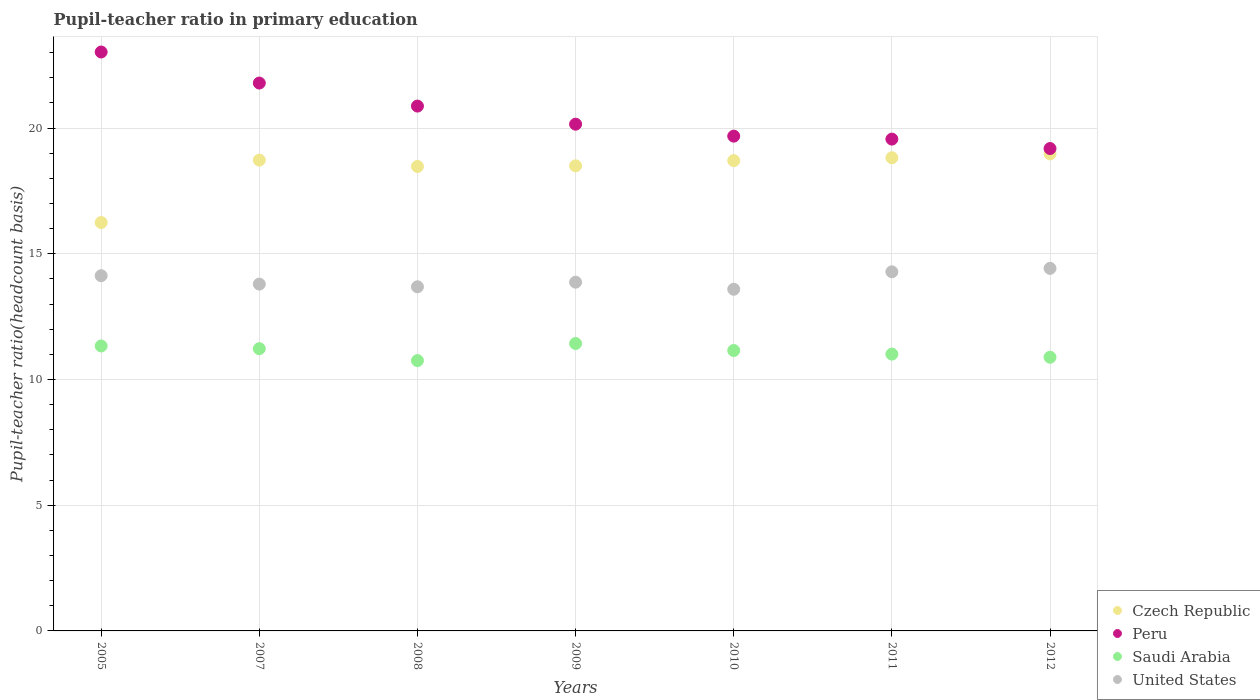How many different coloured dotlines are there?
Make the answer very short. 4. Is the number of dotlines equal to the number of legend labels?
Ensure brevity in your answer.  Yes. What is the pupil-teacher ratio in primary education in Peru in 2012?
Offer a very short reply. 19.19. Across all years, what is the maximum pupil-teacher ratio in primary education in Czech Republic?
Offer a terse response. 18.97. Across all years, what is the minimum pupil-teacher ratio in primary education in Saudi Arabia?
Provide a succinct answer. 10.75. In which year was the pupil-teacher ratio in primary education in Czech Republic maximum?
Give a very brief answer. 2012. What is the total pupil-teacher ratio in primary education in Saudi Arabia in the graph?
Keep it short and to the point. 77.8. What is the difference between the pupil-teacher ratio in primary education in United States in 2005 and that in 2009?
Provide a succinct answer. 0.26. What is the difference between the pupil-teacher ratio in primary education in Peru in 2005 and the pupil-teacher ratio in primary education in United States in 2008?
Offer a very short reply. 9.34. What is the average pupil-teacher ratio in primary education in Czech Republic per year?
Give a very brief answer. 18.35. In the year 2008, what is the difference between the pupil-teacher ratio in primary education in Peru and pupil-teacher ratio in primary education in Czech Republic?
Make the answer very short. 2.4. What is the ratio of the pupil-teacher ratio in primary education in Peru in 2007 to that in 2009?
Your response must be concise. 1.08. Is the pupil-teacher ratio in primary education in United States in 2010 less than that in 2011?
Ensure brevity in your answer.  Yes. What is the difference between the highest and the second highest pupil-teacher ratio in primary education in Peru?
Your answer should be very brief. 1.23. What is the difference between the highest and the lowest pupil-teacher ratio in primary education in Peru?
Your answer should be very brief. 3.84. In how many years, is the pupil-teacher ratio in primary education in Peru greater than the average pupil-teacher ratio in primary education in Peru taken over all years?
Give a very brief answer. 3. Is it the case that in every year, the sum of the pupil-teacher ratio in primary education in Czech Republic and pupil-teacher ratio in primary education in Saudi Arabia  is greater than the sum of pupil-teacher ratio in primary education in Peru and pupil-teacher ratio in primary education in United States?
Offer a very short reply. No. Is it the case that in every year, the sum of the pupil-teacher ratio in primary education in Czech Republic and pupil-teacher ratio in primary education in United States  is greater than the pupil-teacher ratio in primary education in Peru?
Provide a succinct answer. Yes. Does the pupil-teacher ratio in primary education in Peru monotonically increase over the years?
Keep it short and to the point. No. Is the pupil-teacher ratio in primary education in Czech Republic strictly greater than the pupil-teacher ratio in primary education in United States over the years?
Give a very brief answer. Yes. Is the pupil-teacher ratio in primary education in Czech Republic strictly less than the pupil-teacher ratio in primary education in Saudi Arabia over the years?
Keep it short and to the point. No. How many years are there in the graph?
Provide a short and direct response. 7. Are the values on the major ticks of Y-axis written in scientific E-notation?
Provide a short and direct response. No. Where does the legend appear in the graph?
Give a very brief answer. Bottom right. How are the legend labels stacked?
Offer a very short reply. Vertical. What is the title of the graph?
Your answer should be compact. Pupil-teacher ratio in primary education. Does "Netherlands" appear as one of the legend labels in the graph?
Your response must be concise. No. What is the label or title of the Y-axis?
Provide a short and direct response. Pupil-teacher ratio(headcount basis). What is the Pupil-teacher ratio(headcount basis) in Czech Republic in 2005?
Provide a succinct answer. 16.25. What is the Pupil-teacher ratio(headcount basis) in Peru in 2005?
Your response must be concise. 23.03. What is the Pupil-teacher ratio(headcount basis) in Saudi Arabia in 2005?
Offer a terse response. 11.33. What is the Pupil-teacher ratio(headcount basis) in United States in 2005?
Keep it short and to the point. 14.13. What is the Pupil-teacher ratio(headcount basis) in Czech Republic in 2007?
Your answer should be compact. 18.73. What is the Pupil-teacher ratio(headcount basis) of Peru in 2007?
Make the answer very short. 21.79. What is the Pupil-teacher ratio(headcount basis) in Saudi Arabia in 2007?
Give a very brief answer. 11.23. What is the Pupil-teacher ratio(headcount basis) of United States in 2007?
Offer a terse response. 13.8. What is the Pupil-teacher ratio(headcount basis) in Czech Republic in 2008?
Provide a succinct answer. 18.48. What is the Pupil-teacher ratio(headcount basis) in Peru in 2008?
Your answer should be very brief. 20.88. What is the Pupil-teacher ratio(headcount basis) in Saudi Arabia in 2008?
Keep it short and to the point. 10.75. What is the Pupil-teacher ratio(headcount basis) of United States in 2008?
Make the answer very short. 13.69. What is the Pupil-teacher ratio(headcount basis) of Czech Republic in 2009?
Your answer should be very brief. 18.5. What is the Pupil-teacher ratio(headcount basis) in Peru in 2009?
Keep it short and to the point. 20.16. What is the Pupil-teacher ratio(headcount basis) of Saudi Arabia in 2009?
Ensure brevity in your answer.  11.43. What is the Pupil-teacher ratio(headcount basis) in United States in 2009?
Your answer should be very brief. 13.87. What is the Pupil-teacher ratio(headcount basis) of Czech Republic in 2010?
Keep it short and to the point. 18.71. What is the Pupil-teacher ratio(headcount basis) of Peru in 2010?
Offer a terse response. 19.68. What is the Pupil-teacher ratio(headcount basis) in Saudi Arabia in 2010?
Your response must be concise. 11.15. What is the Pupil-teacher ratio(headcount basis) in United States in 2010?
Provide a short and direct response. 13.59. What is the Pupil-teacher ratio(headcount basis) of Czech Republic in 2011?
Offer a terse response. 18.82. What is the Pupil-teacher ratio(headcount basis) of Peru in 2011?
Offer a terse response. 19.56. What is the Pupil-teacher ratio(headcount basis) in Saudi Arabia in 2011?
Make the answer very short. 11.01. What is the Pupil-teacher ratio(headcount basis) in United States in 2011?
Your answer should be compact. 14.29. What is the Pupil-teacher ratio(headcount basis) in Czech Republic in 2012?
Your answer should be very brief. 18.97. What is the Pupil-teacher ratio(headcount basis) in Peru in 2012?
Your answer should be very brief. 19.19. What is the Pupil-teacher ratio(headcount basis) of Saudi Arabia in 2012?
Offer a very short reply. 10.89. What is the Pupil-teacher ratio(headcount basis) in United States in 2012?
Your response must be concise. 14.42. Across all years, what is the maximum Pupil-teacher ratio(headcount basis) in Czech Republic?
Provide a short and direct response. 18.97. Across all years, what is the maximum Pupil-teacher ratio(headcount basis) of Peru?
Offer a very short reply. 23.03. Across all years, what is the maximum Pupil-teacher ratio(headcount basis) in Saudi Arabia?
Offer a very short reply. 11.43. Across all years, what is the maximum Pupil-teacher ratio(headcount basis) of United States?
Offer a very short reply. 14.42. Across all years, what is the minimum Pupil-teacher ratio(headcount basis) in Czech Republic?
Give a very brief answer. 16.25. Across all years, what is the minimum Pupil-teacher ratio(headcount basis) in Peru?
Give a very brief answer. 19.19. Across all years, what is the minimum Pupil-teacher ratio(headcount basis) in Saudi Arabia?
Ensure brevity in your answer.  10.75. Across all years, what is the minimum Pupil-teacher ratio(headcount basis) in United States?
Offer a very short reply. 13.59. What is the total Pupil-teacher ratio(headcount basis) of Czech Republic in the graph?
Make the answer very short. 128.45. What is the total Pupil-teacher ratio(headcount basis) of Peru in the graph?
Your answer should be very brief. 144.29. What is the total Pupil-teacher ratio(headcount basis) in Saudi Arabia in the graph?
Your answer should be very brief. 77.8. What is the total Pupil-teacher ratio(headcount basis) of United States in the graph?
Keep it short and to the point. 97.78. What is the difference between the Pupil-teacher ratio(headcount basis) of Czech Republic in 2005 and that in 2007?
Make the answer very short. -2.48. What is the difference between the Pupil-teacher ratio(headcount basis) of Peru in 2005 and that in 2007?
Make the answer very short. 1.23. What is the difference between the Pupil-teacher ratio(headcount basis) of Saudi Arabia in 2005 and that in 2007?
Keep it short and to the point. 0.11. What is the difference between the Pupil-teacher ratio(headcount basis) in United States in 2005 and that in 2007?
Keep it short and to the point. 0.33. What is the difference between the Pupil-teacher ratio(headcount basis) in Czech Republic in 2005 and that in 2008?
Provide a short and direct response. -2.23. What is the difference between the Pupil-teacher ratio(headcount basis) in Peru in 2005 and that in 2008?
Provide a short and direct response. 2.15. What is the difference between the Pupil-teacher ratio(headcount basis) of Saudi Arabia in 2005 and that in 2008?
Provide a short and direct response. 0.58. What is the difference between the Pupil-teacher ratio(headcount basis) in United States in 2005 and that in 2008?
Your answer should be very brief. 0.44. What is the difference between the Pupil-teacher ratio(headcount basis) of Czech Republic in 2005 and that in 2009?
Make the answer very short. -2.26. What is the difference between the Pupil-teacher ratio(headcount basis) in Peru in 2005 and that in 2009?
Offer a terse response. 2.87. What is the difference between the Pupil-teacher ratio(headcount basis) of Saudi Arabia in 2005 and that in 2009?
Offer a very short reply. -0.1. What is the difference between the Pupil-teacher ratio(headcount basis) in United States in 2005 and that in 2009?
Offer a very short reply. 0.26. What is the difference between the Pupil-teacher ratio(headcount basis) of Czech Republic in 2005 and that in 2010?
Offer a very short reply. -2.46. What is the difference between the Pupil-teacher ratio(headcount basis) of Peru in 2005 and that in 2010?
Ensure brevity in your answer.  3.35. What is the difference between the Pupil-teacher ratio(headcount basis) of Saudi Arabia in 2005 and that in 2010?
Your answer should be compact. 0.18. What is the difference between the Pupil-teacher ratio(headcount basis) in United States in 2005 and that in 2010?
Your answer should be compact. 0.54. What is the difference between the Pupil-teacher ratio(headcount basis) in Czech Republic in 2005 and that in 2011?
Offer a very short reply. -2.58. What is the difference between the Pupil-teacher ratio(headcount basis) of Peru in 2005 and that in 2011?
Provide a short and direct response. 3.46. What is the difference between the Pupil-teacher ratio(headcount basis) of Saudi Arabia in 2005 and that in 2011?
Provide a short and direct response. 0.32. What is the difference between the Pupil-teacher ratio(headcount basis) in United States in 2005 and that in 2011?
Your answer should be very brief. -0.16. What is the difference between the Pupil-teacher ratio(headcount basis) of Czech Republic in 2005 and that in 2012?
Provide a short and direct response. -2.73. What is the difference between the Pupil-teacher ratio(headcount basis) of Peru in 2005 and that in 2012?
Keep it short and to the point. 3.84. What is the difference between the Pupil-teacher ratio(headcount basis) in Saudi Arabia in 2005 and that in 2012?
Make the answer very short. 0.45. What is the difference between the Pupil-teacher ratio(headcount basis) in United States in 2005 and that in 2012?
Your answer should be very brief. -0.29. What is the difference between the Pupil-teacher ratio(headcount basis) of Czech Republic in 2007 and that in 2008?
Give a very brief answer. 0.25. What is the difference between the Pupil-teacher ratio(headcount basis) of Peru in 2007 and that in 2008?
Your response must be concise. 0.92. What is the difference between the Pupil-teacher ratio(headcount basis) of Saudi Arabia in 2007 and that in 2008?
Provide a succinct answer. 0.47. What is the difference between the Pupil-teacher ratio(headcount basis) of United States in 2007 and that in 2008?
Your response must be concise. 0.11. What is the difference between the Pupil-teacher ratio(headcount basis) in Czech Republic in 2007 and that in 2009?
Your response must be concise. 0.23. What is the difference between the Pupil-teacher ratio(headcount basis) of Peru in 2007 and that in 2009?
Ensure brevity in your answer.  1.64. What is the difference between the Pupil-teacher ratio(headcount basis) of Saudi Arabia in 2007 and that in 2009?
Provide a succinct answer. -0.2. What is the difference between the Pupil-teacher ratio(headcount basis) in United States in 2007 and that in 2009?
Keep it short and to the point. -0.08. What is the difference between the Pupil-teacher ratio(headcount basis) in Czech Republic in 2007 and that in 2010?
Provide a short and direct response. 0.02. What is the difference between the Pupil-teacher ratio(headcount basis) of Peru in 2007 and that in 2010?
Ensure brevity in your answer.  2.11. What is the difference between the Pupil-teacher ratio(headcount basis) in Saudi Arabia in 2007 and that in 2010?
Provide a succinct answer. 0.07. What is the difference between the Pupil-teacher ratio(headcount basis) in United States in 2007 and that in 2010?
Provide a succinct answer. 0.2. What is the difference between the Pupil-teacher ratio(headcount basis) of Czech Republic in 2007 and that in 2011?
Ensure brevity in your answer.  -0.09. What is the difference between the Pupil-teacher ratio(headcount basis) of Peru in 2007 and that in 2011?
Ensure brevity in your answer.  2.23. What is the difference between the Pupil-teacher ratio(headcount basis) in Saudi Arabia in 2007 and that in 2011?
Your answer should be very brief. 0.22. What is the difference between the Pupil-teacher ratio(headcount basis) of United States in 2007 and that in 2011?
Keep it short and to the point. -0.49. What is the difference between the Pupil-teacher ratio(headcount basis) in Czech Republic in 2007 and that in 2012?
Provide a succinct answer. -0.25. What is the difference between the Pupil-teacher ratio(headcount basis) in Peru in 2007 and that in 2012?
Your answer should be compact. 2.6. What is the difference between the Pupil-teacher ratio(headcount basis) of Saudi Arabia in 2007 and that in 2012?
Ensure brevity in your answer.  0.34. What is the difference between the Pupil-teacher ratio(headcount basis) in United States in 2007 and that in 2012?
Provide a succinct answer. -0.63. What is the difference between the Pupil-teacher ratio(headcount basis) in Czech Republic in 2008 and that in 2009?
Give a very brief answer. -0.03. What is the difference between the Pupil-teacher ratio(headcount basis) in Peru in 2008 and that in 2009?
Keep it short and to the point. 0.72. What is the difference between the Pupil-teacher ratio(headcount basis) of Saudi Arabia in 2008 and that in 2009?
Give a very brief answer. -0.68. What is the difference between the Pupil-teacher ratio(headcount basis) in United States in 2008 and that in 2009?
Offer a very short reply. -0.18. What is the difference between the Pupil-teacher ratio(headcount basis) in Czech Republic in 2008 and that in 2010?
Your response must be concise. -0.23. What is the difference between the Pupil-teacher ratio(headcount basis) of Peru in 2008 and that in 2010?
Provide a succinct answer. 1.2. What is the difference between the Pupil-teacher ratio(headcount basis) of Saudi Arabia in 2008 and that in 2010?
Your response must be concise. -0.4. What is the difference between the Pupil-teacher ratio(headcount basis) in United States in 2008 and that in 2010?
Ensure brevity in your answer.  0.1. What is the difference between the Pupil-teacher ratio(headcount basis) in Czech Republic in 2008 and that in 2011?
Your answer should be compact. -0.35. What is the difference between the Pupil-teacher ratio(headcount basis) of Peru in 2008 and that in 2011?
Offer a terse response. 1.31. What is the difference between the Pupil-teacher ratio(headcount basis) in Saudi Arabia in 2008 and that in 2011?
Your answer should be compact. -0.26. What is the difference between the Pupil-teacher ratio(headcount basis) in United States in 2008 and that in 2011?
Offer a very short reply. -0.6. What is the difference between the Pupil-teacher ratio(headcount basis) of Czech Republic in 2008 and that in 2012?
Your answer should be very brief. -0.5. What is the difference between the Pupil-teacher ratio(headcount basis) of Peru in 2008 and that in 2012?
Offer a terse response. 1.69. What is the difference between the Pupil-teacher ratio(headcount basis) of Saudi Arabia in 2008 and that in 2012?
Offer a very short reply. -0.13. What is the difference between the Pupil-teacher ratio(headcount basis) in United States in 2008 and that in 2012?
Your answer should be very brief. -0.73. What is the difference between the Pupil-teacher ratio(headcount basis) of Czech Republic in 2009 and that in 2010?
Offer a terse response. -0.21. What is the difference between the Pupil-teacher ratio(headcount basis) of Peru in 2009 and that in 2010?
Provide a succinct answer. 0.48. What is the difference between the Pupil-teacher ratio(headcount basis) of Saudi Arabia in 2009 and that in 2010?
Your response must be concise. 0.28. What is the difference between the Pupil-teacher ratio(headcount basis) of United States in 2009 and that in 2010?
Keep it short and to the point. 0.28. What is the difference between the Pupil-teacher ratio(headcount basis) of Czech Republic in 2009 and that in 2011?
Your answer should be compact. -0.32. What is the difference between the Pupil-teacher ratio(headcount basis) in Peru in 2009 and that in 2011?
Provide a succinct answer. 0.59. What is the difference between the Pupil-teacher ratio(headcount basis) in Saudi Arabia in 2009 and that in 2011?
Keep it short and to the point. 0.42. What is the difference between the Pupil-teacher ratio(headcount basis) in United States in 2009 and that in 2011?
Keep it short and to the point. -0.41. What is the difference between the Pupil-teacher ratio(headcount basis) of Czech Republic in 2009 and that in 2012?
Your answer should be compact. -0.47. What is the difference between the Pupil-teacher ratio(headcount basis) of Peru in 2009 and that in 2012?
Provide a short and direct response. 0.97. What is the difference between the Pupil-teacher ratio(headcount basis) of Saudi Arabia in 2009 and that in 2012?
Offer a terse response. 0.54. What is the difference between the Pupil-teacher ratio(headcount basis) of United States in 2009 and that in 2012?
Give a very brief answer. -0.55. What is the difference between the Pupil-teacher ratio(headcount basis) of Czech Republic in 2010 and that in 2011?
Offer a terse response. -0.11. What is the difference between the Pupil-teacher ratio(headcount basis) in Peru in 2010 and that in 2011?
Offer a very short reply. 0.12. What is the difference between the Pupil-teacher ratio(headcount basis) in Saudi Arabia in 2010 and that in 2011?
Offer a very short reply. 0.14. What is the difference between the Pupil-teacher ratio(headcount basis) in United States in 2010 and that in 2011?
Your answer should be very brief. -0.69. What is the difference between the Pupil-teacher ratio(headcount basis) of Czech Republic in 2010 and that in 2012?
Offer a very short reply. -0.27. What is the difference between the Pupil-teacher ratio(headcount basis) of Peru in 2010 and that in 2012?
Your answer should be compact. 0.49. What is the difference between the Pupil-teacher ratio(headcount basis) of Saudi Arabia in 2010 and that in 2012?
Offer a very short reply. 0.27. What is the difference between the Pupil-teacher ratio(headcount basis) of United States in 2010 and that in 2012?
Make the answer very short. -0.83. What is the difference between the Pupil-teacher ratio(headcount basis) in Czech Republic in 2011 and that in 2012?
Ensure brevity in your answer.  -0.15. What is the difference between the Pupil-teacher ratio(headcount basis) of Peru in 2011 and that in 2012?
Provide a short and direct response. 0.38. What is the difference between the Pupil-teacher ratio(headcount basis) in Saudi Arabia in 2011 and that in 2012?
Provide a succinct answer. 0.12. What is the difference between the Pupil-teacher ratio(headcount basis) in United States in 2011 and that in 2012?
Offer a very short reply. -0.14. What is the difference between the Pupil-teacher ratio(headcount basis) of Czech Republic in 2005 and the Pupil-teacher ratio(headcount basis) of Peru in 2007?
Offer a terse response. -5.55. What is the difference between the Pupil-teacher ratio(headcount basis) in Czech Republic in 2005 and the Pupil-teacher ratio(headcount basis) in Saudi Arabia in 2007?
Make the answer very short. 5.02. What is the difference between the Pupil-teacher ratio(headcount basis) in Czech Republic in 2005 and the Pupil-teacher ratio(headcount basis) in United States in 2007?
Keep it short and to the point. 2.45. What is the difference between the Pupil-teacher ratio(headcount basis) of Peru in 2005 and the Pupil-teacher ratio(headcount basis) of Saudi Arabia in 2007?
Provide a short and direct response. 11.8. What is the difference between the Pupil-teacher ratio(headcount basis) of Peru in 2005 and the Pupil-teacher ratio(headcount basis) of United States in 2007?
Your response must be concise. 9.23. What is the difference between the Pupil-teacher ratio(headcount basis) in Saudi Arabia in 2005 and the Pupil-teacher ratio(headcount basis) in United States in 2007?
Your answer should be compact. -2.46. What is the difference between the Pupil-teacher ratio(headcount basis) in Czech Republic in 2005 and the Pupil-teacher ratio(headcount basis) in Peru in 2008?
Make the answer very short. -4.63. What is the difference between the Pupil-teacher ratio(headcount basis) in Czech Republic in 2005 and the Pupil-teacher ratio(headcount basis) in Saudi Arabia in 2008?
Ensure brevity in your answer.  5.49. What is the difference between the Pupil-teacher ratio(headcount basis) of Czech Republic in 2005 and the Pupil-teacher ratio(headcount basis) of United States in 2008?
Keep it short and to the point. 2.56. What is the difference between the Pupil-teacher ratio(headcount basis) of Peru in 2005 and the Pupil-teacher ratio(headcount basis) of Saudi Arabia in 2008?
Your answer should be compact. 12.27. What is the difference between the Pupil-teacher ratio(headcount basis) in Peru in 2005 and the Pupil-teacher ratio(headcount basis) in United States in 2008?
Your response must be concise. 9.34. What is the difference between the Pupil-teacher ratio(headcount basis) in Saudi Arabia in 2005 and the Pupil-teacher ratio(headcount basis) in United States in 2008?
Your response must be concise. -2.35. What is the difference between the Pupil-teacher ratio(headcount basis) of Czech Republic in 2005 and the Pupil-teacher ratio(headcount basis) of Peru in 2009?
Give a very brief answer. -3.91. What is the difference between the Pupil-teacher ratio(headcount basis) of Czech Republic in 2005 and the Pupil-teacher ratio(headcount basis) of Saudi Arabia in 2009?
Give a very brief answer. 4.81. What is the difference between the Pupil-teacher ratio(headcount basis) in Czech Republic in 2005 and the Pupil-teacher ratio(headcount basis) in United States in 2009?
Ensure brevity in your answer.  2.37. What is the difference between the Pupil-teacher ratio(headcount basis) in Peru in 2005 and the Pupil-teacher ratio(headcount basis) in Saudi Arabia in 2009?
Provide a succinct answer. 11.6. What is the difference between the Pupil-teacher ratio(headcount basis) in Peru in 2005 and the Pupil-teacher ratio(headcount basis) in United States in 2009?
Offer a terse response. 9.16. What is the difference between the Pupil-teacher ratio(headcount basis) in Saudi Arabia in 2005 and the Pupil-teacher ratio(headcount basis) in United States in 2009?
Your response must be concise. -2.54. What is the difference between the Pupil-teacher ratio(headcount basis) of Czech Republic in 2005 and the Pupil-teacher ratio(headcount basis) of Peru in 2010?
Make the answer very short. -3.44. What is the difference between the Pupil-teacher ratio(headcount basis) of Czech Republic in 2005 and the Pupil-teacher ratio(headcount basis) of Saudi Arabia in 2010?
Provide a succinct answer. 5.09. What is the difference between the Pupil-teacher ratio(headcount basis) of Czech Republic in 2005 and the Pupil-teacher ratio(headcount basis) of United States in 2010?
Provide a succinct answer. 2.65. What is the difference between the Pupil-teacher ratio(headcount basis) of Peru in 2005 and the Pupil-teacher ratio(headcount basis) of Saudi Arabia in 2010?
Provide a succinct answer. 11.87. What is the difference between the Pupil-teacher ratio(headcount basis) of Peru in 2005 and the Pupil-teacher ratio(headcount basis) of United States in 2010?
Give a very brief answer. 9.44. What is the difference between the Pupil-teacher ratio(headcount basis) in Saudi Arabia in 2005 and the Pupil-teacher ratio(headcount basis) in United States in 2010?
Ensure brevity in your answer.  -2.26. What is the difference between the Pupil-teacher ratio(headcount basis) in Czech Republic in 2005 and the Pupil-teacher ratio(headcount basis) in Peru in 2011?
Make the answer very short. -3.32. What is the difference between the Pupil-teacher ratio(headcount basis) of Czech Republic in 2005 and the Pupil-teacher ratio(headcount basis) of Saudi Arabia in 2011?
Give a very brief answer. 5.23. What is the difference between the Pupil-teacher ratio(headcount basis) in Czech Republic in 2005 and the Pupil-teacher ratio(headcount basis) in United States in 2011?
Your answer should be compact. 1.96. What is the difference between the Pupil-teacher ratio(headcount basis) of Peru in 2005 and the Pupil-teacher ratio(headcount basis) of Saudi Arabia in 2011?
Your response must be concise. 12.02. What is the difference between the Pupil-teacher ratio(headcount basis) of Peru in 2005 and the Pupil-teacher ratio(headcount basis) of United States in 2011?
Keep it short and to the point. 8.74. What is the difference between the Pupil-teacher ratio(headcount basis) of Saudi Arabia in 2005 and the Pupil-teacher ratio(headcount basis) of United States in 2011?
Ensure brevity in your answer.  -2.95. What is the difference between the Pupil-teacher ratio(headcount basis) in Czech Republic in 2005 and the Pupil-teacher ratio(headcount basis) in Peru in 2012?
Your answer should be very brief. -2.94. What is the difference between the Pupil-teacher ratio(headcount basis) of Czech Republic in 2005 and the Pupil-teacher ratio(headcount basis) of Saudi Arabia in 2012?
Your answer should be compact. 5.36. What is the difference between the Pupil-teacher ratio(headcount basis) of Czech Republic in 2005 and the Pupil-teacher ratio(headcount basis) of United States in 2012?
Offer a terse response. 1.82. What is the difference between the Pupil-teacher ratio(headcount basis) of Peru in 2005 and the Pupil-teacher ratio(headcount basis) of Saudi Arabia in 2012?
Provide a succinct answer. 12.14. What is the difference between the Pupil-teacher ratio(headcount basis) of Peru in 2005 and the Pupil-teacher ratio(headcount basis) of United States in 2012?
Offer a very short reply. 8.61. What is the difference between the Pupil-teacher ratio(headcount basis) in Saudi Arabia in 2005 and the Pupil-teacher ratio(headcount basis) in United States in 2012?
Offer a very short reply. -3.09. What is the difference between the Pupil-teacher ratio(headcount basis) of Czech Republic in 2007 and the Pupil-teacher ratio(headcount basis) of Peru in 2008?
Provide a succinct answer. -2.15. What is the difference between the Pupil-teacher ratio(headcount basis) in Czech Republic in 2007 and the Pupil-teacher ratio(headcount basis) in Saudi Arabia in 2008?
Give a very brief answer. 7.97. What is the difference between the Pupil-teacher ratio(headcount basis) of Czech Republic in 2007 and the Pupil-teacher ratio(headcount basis) of United States in 2008?
Offer a very short reply. 5.04. What is the difference between the Pupil-teacher ratio(headcount basis) of Peru in 2007 and the Pupil-teacher ratio(headcount basis) of Saudi Arabia in 2008?
Your answer should be very brief. 11.04. What is the difference between the Pupil-teacher ratio(headcount basis) in Peru in 2007 and the Pupil-teacher ratio(headcount basis) in United States in 2008?
Your answer should be very brief. 8.1. What is the difference between the Pupil-teacher ratio(headcount basis) in Saudi Arabia in 2007 and the Pupil-teacher ratio(headcount basis) in United States in 2008?
Your answer should be compact. -2.46. What is the difference between the Pupil-teacher ratio(headcount basis) of Czech Republic in 2007 and the Pupil-teacher ratio(headcount basis) of Peru in 2009?
Keep it short and to the point. -1.43. What is the difference between the Pupil-teacher ratio(headcount basis) in Czech Republic in 2007 and the Pupil-teacher ratio(headcount basis) in Saudi Arabia in 2009?
Give a very brief answer. 7.3. What is the difference between the Pupil-teacher ratio(headcount basis) of Czech Republic in 2007 and the Pupil-teacher ratio(headcount basis) of United States in 2009?
Ensure brevity in your answer.  4.86. What is the difference between the Pupil-teacher ratio(headcount basis) of Peru in 2007 and the Pupil-teacher ratio(headcount basis) of Saudi Arabia in 2009?
Make the answer very short. 10.36. What is the difference between the Pupil-teacher ratio(headcount basis) in Peru in 2007 and the Pupil-teacher ratio(headcount basis) in United States in 2009?
Provide a succinct answer. 7.92. What is the difference between the Pupil-teacher ratio(headcount basis) of Saudi Arabia in 2007 and the Pupil-teacher ratio(headcount basis) of United States in 2009?
Ensure brevity in your answer.  -2.65. What is the difference between the Pupil-teacher ratio(headcount basis) in Czech Republic in 2007 and the Pupil-teacher ratio(headcount basis) in Peru in 2010?
Offer a terse response. -0.95. What is the difference between the Pupil-teacher ratio(headcount basis) in Czech Republic in 2007 and the Pupil-teacher ratio(headcount basis) in Saudi Arabia in 2010?
Provide a short and direct response. 7.57. What is the difference between the Pupil-teacher ratio(headcount basis) of Czech Republic in 2007 and the Pupil-teacher ratio(headcount basis) of United States in 2010?
Offer a very short reply. 5.14. What is the difference between the Pupil-teacher ratio(headcount basis) in Peru in 2007 and the Pupil-teacher ratio(headcount basis) in Saudi Arabia in 2010?
Your answer should be compact. 10.64. What is the difference between the Pupil-teacher ratio(headcount basis) in Peru in 2007 and the Pupil-teacher ratio(headcount basis) in United States in 2010?
Offer a very short reply. 8.2. What is the difference between the Pupil-teacher ratio(headcount basis) in Saudi Arabia in 2007 and the Pupil-teacher ratio(headcount basis) in United States in 2010?
Provide a succinct answer. -2.36. What is the difference between the Pupil-teacher ratio(headcount basis) in Czech Republic in 2007 and the Pupil-teacher ratio(headcount basis) in Peru in 2011?
Give a very brief answer. -0.84. What is the difference between the Pupil-teacher ratio(headcount basis) in Czech Republic in 2007 and the Pupil-teacher ratio(headcount basis) in Saudi Arabia in 2011?
Give a very brief answer. 7.72. What is the difference between the Pupil-teacher ratio(headcount basis) in Czech Republic in 2007 and the Pupil-teacher ratio(headcount basis) in United States in 2011?
Make the answer very short. 4.44. What is the difference between the Pupil-teacher ratio(headcount basis) in Peru in 2007 and the Pupil-teacher ratio(headcount basis) in Saudi Arabia in 2011?
Provide a succinct answer. 10.78. What is the difference between the Pupil-teacher ratio(headcount basis) of Peru in 2007 and the Pupil-teacher ratio(headcount basis) of United States in 2011?
Offer a very short reply. 7.51. What is the difference between the Pupil-teacher ratio(headcount basis) of Saudi Arabia in 2007 and the Pupil-teacher ratio(headcount basis) of United States in 2011?
Give a very brief answer. -3.06. What is the difference between the Pupil-teacher ratio(headcount basis) in Czech Republic in 2007 and the Pupil-teacher ratio(headcount basis) in Peru in 2012?
Keep it short and to the point. -0.46. What is the difference between the Pupil-teacher ratio(headcount basis) of Czech Republic in 2007 and the Pupil-teacher ratio(headcount basis) of Saudi Arabia in 2012?
Offer a terse response. 7.84. What is the difference between the Pupil-teacher ratio(headcount basis) in Czech Republic in 2007 and the Pupil-teacher ratio(headcount basis) in United States in 2012?
Provide a succinct answer. 4.31. What is the difference between the Pupil-teacher ratio(headcount basis) in Peru in 2007 and the Pupil-teacher ratio(headcount basis) in Saudi Arabia in 2012?
Provide a succinct answer. 10.91. What is the difference between the Pupil-teacher ratio(headcount basis) in Peru in 2007 and the Pupil-teacher ratio(headcount basis) in United States in 2012?
Offer a terse response. 7.37. What is the difference between the Pupil-teacher ratio(headcount basis) in Saudi Arabia in 2007 and the Pupil-teacher ratio(headcount basis) in United States in 2012?
Keep it short and to the point. -3.2. What is the difference between the Pupil-teacher ratio(headcount basis) of Czech Republic in 2008 and the Pupil-teacher ratio(headcount basis) of Peru in 2009?
Your answer should be very brief. -1.68. What is the difference between the Pupil-teacher ratio(headcount basis) of Czech Republic in 2008 and the Pupil-teacher ratio(headcount basis) of Saudi Arabia in 2009?
Keep it short and to the point. 7.04. What is the difference between the Pupil-teacher ratio(headcount basis) of Czech Republic in 2008 and the Pupil-teacher ratio(headcount basis) of United States in 2009?
Ensure brevity in your answer.  4.6. What is the difference between the Pupil-teacher ratio(headcount basis) of Peru in 2008 and the Pupil-teacher ratio(headcount basis) of Saudi Arabia in 2009?
Make the answer very short. 9.45. What is the difference between the Pupil-teacher ratio(headcount basis) in Peru in 2008 and the Pupil-teacher ratio(headcount basis) in United States in 2009?
Provide a succinct answer. 7. What is the difference between the Pupil-teacher ratio(headcount basis) of Saudi Arabia in 2008 and the Pupil-teacher ratio(headcount basis) of United States in 2009?
Your response must be concise. -3.12. What is the difference between the Pupil-teacher ratio(headcount basis) in Czech Republic in 2008 and the Pupil-teacher ratio(headcount basis) in Peru in 2010?
Your response must be concise. -1.21. What is the difference between the Pupil-teacher ratio(headcount basis) in Czech Republic in 2008 and the Pupil-teacher ratio(headcount basis) in Saudi Arabia in 2010?
Offer a very short reply. 7.32. What is the difference between the Pupil-teacher ratio(headcount basis) of Czech Republic in 2008 and the Pupil-teacher ratio(headcount basis) of United States in 2010?
Make the answer very short. 4.88. What is the difference between the Pupil-teacher ratio(headcount basis) of Peru in 2008 and the Pupil-teacher ratio(headcount basis) of Saudi Arabia in 2010?
Provide a short and direct response. 9.72. What is the difference between the Pupil-teacher ratio(headcount basis) of Peru in 2008 and the Pupil-teacher ratio(headcount basis) of United States in 2010?
Offer a terse response. 7.29. What is the difference between the Pupil-teacher ratio(headcount basis) of Saudi Arabia in 2008 and the Pupil-teacher ratio(headcount basis) of United States in 2010?
Your response must be concise. -2.84. What is the difference between the Pupil-teacher ratio(headcount basis) in Czech Republic in 2008 and the Pupil-teacher ratio(headcount basis) in Peru in 2011?
Provide a succinct answer. -1.09. What is the difference between the Pupil-teacher ratio(headcount basis) in Czech Republic in 2008 and the Pupil-teacher ratio(headcount basis) in Saudi Arabia in 2011?
Your answer should be compact. 7.46. What is the difference between the Pupil-teacher ratio(headcount basis) in Czech Republic in 2008 and the Pupil-teacher ratio(headcount basis) in United States in 2011?
Provide a short and direct response. 4.19. What is the difference between the Pupil-teacher ratio(headcount basis) in Peru in 2008 and the Pupil-teacher ratio(headcount basis) in Saudi Arabia in 2011?
Provide a succinct answer. 9.87. What is the difference between the Pupil-teacher ratio(headcount basis) of Peru in 2008 and the Pupil-teacher ratio(headcount basis) of United States in 2011?
Your answer should be very brief. 6.59. What is the difference between the Pupil-teacher ratio(headcount basis) of Saudi Arabia in 2008 and the Pupil-teacher ratio(headcount basis) of United States in 2011?
Ensure brevity in your answer.  -3.53. What is the difference between the Pupil-teacher ratio(headcount basis) of Czech Republic in 2008 and the Pupil-teacher ratio(headcount basis) of Peru in 2012?
Offer a terse response. -0.71. What is the difference between the Pupil-teacher ratio(headcount basis) of Czech Republic in 2008 and the Pupil-teacher ratio(headcount basis) of Saudi Arabia in 2012?
Offer a terse response. 7.59. What is the difference between the Pupil-teacher ratio(headcount basis) of Czech Republic in 2008 and the Pupil-teacher ratio(headcount basis) of United States in 2012?
Ensure brevity in your answer.  4.05. What is the difference between the Pupil-teacher ratio(headcount basis) in Peru in 2008 and the Pupil-teacher ratio(headcount basis) in Saudi Arabia in 2012?
Offer a terse response. 9.99. What is the difference between the Pupil-teacher ratio(headcount basis) of Peru in 2008 and the Pupil-teacher ratio(headcount basis) of United States in 2012?
Make the answer very short. 6.45. What is the difference between the Pupil-teacher ratio(headcount basis) of Saudi Arabia in 2008 and the Pupil-teacher ratio(headcount basis) of United States in 2012?
Provide a short and direct response. -3.67. What is the difference between the Pupil-teacher ratio(headcount basis) in Czech Republic in 2009 and the Pupil-teacher ratio(headcount basis) in Peru in 2010?
Provide a succinct answer. -1.18. What is the difference between the Pupil-teacher ratio(headcount basis) in Czech Republic in 2009 and the Pupil-teacher ratio(headcount basis) in Saudi Arabia in 2010?
Provide a short and direct response. 7.35. What is the difference between the Pupil-teacher ratio(headcount basis) in Czech Republic in 2009 and the Pupil-teacher ratio(headcount basis) in United States in 2010?
Offer a very short reply. 4.91. What is the difference between the Pupil-teacher ratio(headcount basis) in Peru in 2009 and the Pupil-teacher ratio(headcount basis) in Saudi Arabia in 2010?
Your answer should be compact. 9. What is the difference between the Pupil-teacher ratio(headcount basis) of Peru in 2009 and the Pupil-teacher ratio(headcount basis) of United States in 2010?
Provide a short and direct response. 6.57. What is the difference between the Pupil-teacher ratio(headcount basis) of Saudi Arabia in 2009 and the Pupil-teacher ratio(headcount basis) of United States in 2010?
Offer a very short reply. -2.16. What is the difference between the Pupil-teacher ratio(headcount basis) of Czech Republic in 2009 and the Pupil-teacher ratio(headcount basis) of Peru in 2011?
Make the answer very short. -1.06. What is the difference between the Pupil-teacher ratio(headcount basis) of Czech Republic in 2009 and the Pupil-teacher ratio(headcount basis) of Saudi Arabia in 2011?
Provide a short and direct response. 7.49. What is the difference between the Pupil-teacher ratio(headcount basis) of Czech Republic in 2009 and the Pupil-teacher ratio(headcount basis) of United States in 2011?
Your answer should be very brief. 4.22. What is the difference between the Pupil-teacher ratio(headcount basis) of Peru in 2009 and the Pupil-teacher ratio(headcount basis) of Saudi Arabia in 2011?
Make the answer very short. 9.15. What is the difference between the Pupil-teacher ratio(headcount basis) in Peru in 2009 and the Pupil-teacher ratio(headcount basis) in United States in 2011?
Your answer should be compact. 5.87. What is the difference between the Pupil-teacher ratio(headcount basis) in Saudi Arabia in 2009 and the Pupil-teacher ratio(headcount basis) in United States in 2011?
Your answer should be compact. -2.85. What is the difference between the Pupil-teacher ratio(headcount basis) in Czech Republic in 2009 and the Pupil-teacher ratio(headcount basis) in Peru in 2012?
Ensure brevity in your answer.  -0.69. What is the difference between the Pupil-teacher ratio(headcount basis) in Czech Republic in 2009 and the Pupil-teacher ratio(headcount basis) in Saudi Arabia in 2012?
Your answer should be very brief. 7.61. What is the difference between the Pupil-teacher ratio(headcount basis) of Czech Republic in 2009 and the Pupil-teacher ratio(headcount basis) of United States in 2012?
Provide a succinct answer. 4.08. What is the difference between the Pupil-teacher ratio(headcount basis) of Peru in 2009 and the Pupil-teacher ratio(headcount basis) of Saudi Arabia in 2012?
Offer a terse response. 9.27. What is the difference between the Pupil-teacher ratio(headcount basis) in Peru in 2009 and the Pupil-teacher ratio(headcount basis) in United States in 2012?
Your response must be concise. 5.74. What is the difference between the Pupil-teacher ratio(headcount basis) of Saudi Arabia in 2009 and the Pupil-teacher ratio(headcount basis) of United States in 2012?
Your answer should be compact. -2.99. What is the difference between the Pupil-teacher ratio(headcount basis) in Czech Republic in 2010 and the Pupil-teacher ratio(headcount basis) in Peru in 2011?
Make the answer very short. -0.86. What is the difference between the Pupil-teacher ratio(headcount basis) of Czech Republic in 2010 and the Pupil-teacher ratio(headcount basis) of Saudi Arabia in 2011?
Keep it short and to the point. 7.7. What is the difference between the Pupil-teacher ratio(headcount basis) in Czech Republic in 2010 and the Pupil-teacher ratio(headcount basis) in United States in 2011?
Offer a very short reply. 4.42. What is the difference between the Pupil-teacher ratio(headcount basis) of Peru in 2010 and the Pupil-teacher ratio(headcount basis) of Saudi Arabia in 2011?
Provide a short and direct response. 8.67. What is the difference between the Pupil-teacher ratio(headcount basis) of Peru in 2010 and the Pupil-teacher ratio(headcount basis) of United States in 2011?
Keep it short and to the point. 5.4. What is the difference between the Pupil-teacher ratio(headcount basis) in Saudi Arabia in 2010 and the Pupil-teacher ratio(headcount basis) in United States in 2011?
Offer a very short reply. -3.13. What is the difference between the Pupil-teacher ratio(headcount basis) in Czech Republic in 2010 and the Pupil-teacher ratio(headcount basis) in Peru in 2012?
Provide a succinct answer. -0.48. What is the difference between the Pupil-teacher ratio(headcount basis) in Czech Republic in 2010 and the Pupil-teacher ratio(headcount basis) in Saudi Arabia in 2012?
Ensure brevity in your answer.  7.82. What is the difference between the Pupil-teacher ratio(headcount basis) in Czech Republic in 2010 and the Pupil-teacher ratio(headcount basis) in United States in 2012?
Offer a very short reply. 4.29. What is the difference between the Pupil-teacher ratio(headcount basis) in Peru in 2010 and the Pupil-teacher ratio(headcount basis) in Saudi Arabia in 2012?
Your answer should be compact. 8.79. What is the difference between the Pupil-teacher ratio(headcount basis) in Peru in 2010 and the Pupil-teacher ratio(headcount basis) in United States in 2012?
Offer a very short reply. 5.26. What is the difference between the Pupil-teacher ratio(headcount basis) in Saudi Arabia in 2010 and the Pupil-teacher ratio(headcount basis) in United States in 2012?
Keep it short and to the point. -3.27. What is the difference between the Pupil-teacher ratio(headcount basis) of Czech Republic in 2011 and the Pupil-teacher ratio(headcount basis) of Peru in 2012?
Your response must be concise. -0.37. What is the difference between the Pupil-teacher ratio(headcount basis) of Czech Republic in 2011 and the Pupil-teacher ratio(headcount basis) of Saudi Arabia in 2012?
Your answer should be very brief. 7.93. What is the difference between the Pupil-teacher ratio(headcount basis) in Czech Republic in 2011 and the Pupil-teacher ratio(headcount basis) in United States in 2012?
Keep it short and to the point. 4.4. What is the difference between the Pupil-teacher ratio(headcount basis) of Peru in 2011 and the Pupil-teacher ratio(headcount basis) of Saudi Arabia in 2012?
Your answer should be compact. 8.68. What is the difference between the Pupil-teacher ratio(headcount basis) of Peru in 2011 and the Pupil-teacher ratio(headcount basis) of United States in 2012?
Make the answer very short. 5.14. What is the difference between the Pupil-teacher ratio(headcount basis) in Saudi Arabia in 2011 and the Pupil-teacher ratio(headcount basis) in United States in 2012?
Give a very brief answer. -3.41. What is the average Pupil-teacher ratio(headcount basis) of Czech Republic per year?
Your answer should be compact. 18.35. What is the average Pupil-teacher ratio(headcount basis) in Peru per year?
Offer a terse response. 20.61. What is the average Pupil-teacher ratio(headcount basis) of Saudi Arabia per year?
Your answer should be compact. 11.11. What is the average Pupil-teacher ratio(headcount basis) of United States per year?
Keep it short and to the point. 13.97. In the year 2005, what is the difference between the Pupil-teacher ratio(headcount basis) of Czech Republic and Pupil-teacher ratio(headcount basis) of Peru?
Offer a very short reply. -6.78. In the year 2005, what is the difference between the Pupil-teacher ratio(headcount basis) in Czech Republic and Pupil-teacher ratio(headcount basis) in Saudi Arabia?
Make the answer very short. 4.91. In the year 2005, what is the difference between the Pupil-teacher ratio(headcount basis) in Czech Republic and Pupil-teacher ratio(headcount basis) in United States?
Offer a terse response. 2.12. In the year 2005, what is the difference between the Pupil-teacher ratio(headcount basis) of Peru and Pupil-teacher ratio(headcount basis) of Saudi Arabia?
Ensure brevity in your answer.  11.69. In the year 2005, what is the difference between the Pupil-teacher ratio(headcount basis) of Peru and Pupil-teacher ratio(headcount basis) of United States?
Ensure brevity in your answer.  8.9. In the year 2005, what is the difference between the Pupil-teacher ratio(headcount basis) in Saudi Arabia and Pupil-teacher ratio(headcount basis) in United States?
Keep it short and to the point. -2.8. In the year 2007, what is the difference between the Pupil-teacher ratio(headcount basis) of Czech Republic and Pupil-teacher ratio(headcount basis) of Peru?
Offer a terse response. -3.07. In the year 2007, what is the difference between the Pupil-teacher ratio(headcount basis) in Czech Republic and Pupil-teacher ratio(headcount basis) in Saudi Arabia?
Your answer should be compact. 7.5. In the year 2007, what is the difference between the Pupil-teacher ratio(headcount basis) of Czech Republic and Pupil-teacher ratio(headcount basis) of United States?
Provide a succinct answer. 4.93. In the year 2007, what is the difference between the Pupil-teacher ratio(headcount basis) of Peru and Pupil-teacher ratio(headcount basis) of Saudi Arabia?
Keep it short and to the point. 10.57. In the year 2007, what is the difference between the Pupil-teacher ratio(headcount basis) of Peru and Pupil-teacher ratio(headcount basis) of United States?
Give a very brief answer. 8. In the year 2007, what is the difference between the Pupil-teacher ratio(headcount basis) of Saudi Arabia and Pupil-teacher ratio(headcount basis) of United States?
Provide a succinct answer. -2.57. In the year 2008, what is the difference between the Pupil-teacher ratio(headcount basis) in Czech Republic and Pupil-teacher ratio(headcount basis) in Peru?
Your answer should be compact. -2.4. In the year 2008, what is the difference between the Pupil-teacher ratio(headcount basis) in Czech Republic and Pupil-teacher ratio(headcount basis) in Saudi Arabia?
Provide a short and direct response. 7.72. In the year 2008, what is the difference between the Pupil-teacher ratio(headcount basis) in Czech Republic and Pupil-teacher ratio(headcount basis) in United States?
Provide a short and direct response. 4.79. In the year 2008, what is the difference between the Pupil-teacher ratio(headcount basis) of Peru and Pupil-teacher ratio(headcount basis) of Saudi Arabia?
Make the answer very short. 10.12. In the year 2008, what is the difference between the Pupil-teacher ratio(headcount basis) in Peru and Pupil-teacher ratio(headcount basis) in United States?
Make the answer very short. 7.19. In the year 2008, what is the difference between the Pupil-teacher ratio(headcount basis) of Saudi Arabia and Pupil-teacher ratio(headcount basis) of United States?
Give a very brief answer. -2.94. In the year 2009, what is the difference between the Pupil-teacher ratio(headcount basis) in Czech Republic and Pupil-teacher ratio(headcount basis) in Peru?
Offer a very short reply. -1.66. In the year 2009, what is the difference between the Pupil-teacher ratio(headcount basis) in Czech Republic and Pupil-teacher ratio(headcount basis) in Saudi Arabia?
Make the answer very short. 7.07. In the year 2009, what is the difference between the Pupil-teacher ratio(headcount basis) of Czech Republic and Pupil-teacher ratio(headcount basis) of United States?
Ensure brevity in your answer.  4.63. In the year 2009, what is the difference between the Pupil-teacher ratio(headcount basis) in Peru and Pupil-teacher ratio(headcount basis) in Saudi Arabia?
Your answer should be compact. 8.73. In the year 2009, what is the difference between the Pupil-teacher ratio(headcount basis) in Peru and Pupil-teacher ratio(headcount basis) in United States?
Your response must be concise. 6.29. In the year 2009, what is the difference between the Pupil-teacher ratio(headcount basis) of Saudi Arabia and Pupil-teacher ratio(headcount basis) of United States?
Provide a short and direct response. -2.44. In the year 2010, what is the difference between the Pupil-teacher ratio(headcount basis) in Czech Republic and Pupil-teacher ratio(headcount basis) in Peru?
Provide a short and direct response. -0.97. In the year 2010, what is the difference between the Pupil-teacher ratio(headcount basis) in Czech Republic and Pupil-teacher ratio(headcount basis) in Saudi Arabia?
Keep it short and to the point. 7.55. In the year 2010, what is the difference between the Pupil-teacher ratio(headcount basis) in Czech Republic and Pupil-teacher ratio(headcount basis) in United States?
Offer a very short reply. 5.12. In the year 2010, what is the difference between the Pupil-teacher ratio(headcount basis) of Peru and Pupil-teacher ratio(headcount basis) of Saudi Arabia?
Give a very brief answer. 8.53. In the year 2010, what is the difference between the Pupil-teacher ratio(headcount basis) of Peru and Pupil-teacher ratio(headcount basis) of United States?
Your answer should be compact. 6.09. In the year 2010, what is the difference between the Pupil-teacher ratio(headcount basis) of Saudi Arabia and Pupil-teacher ratio(headcount basis) of United States?
Your answer should be compact. -2.44. In the year 2011, what is the difference between the Pupil-teacher ratio(headcount basis) of Czech Republic and Pupil-teacher ratio(headcount basis) of Peru?
Keep it short and to the point. -0.74. In the year 2011, what is the difference between the Pupil-teacher ratio(headcount basis) in Czech Republic and Pupil-teacher ratio(headcount basis) in Saudi Arabia?
Give a very brief answer. 7.81. In the year 2011, what is the difference between the Pupil-teacher ratio(headcount basis) in Czech Republic and Pupil-teacher ratio(headcount basis) in United States?
Your answer should be very brief. 4.54. In the year 2011, what is the difference between the Pupil-teacher ratio(headcount basis) of Peru and Pupil-teacher ratio(headcount basis) of Saudi Arabia?
Your response must be concise. 8.55. In the year 2011, what is the difference between the Pupil-teacher ratio(headcount basis) of Peru and Pupil-teacher ratio(headcount basis) of United States?
Your answer should be very brief. 5.28. In the year 2011, what is the difference between the Pupil-teacher ratio(headcount basis) in Saudi Arabia and Pupil-teacher ratio(headcount basis) in United States?
Ensure brevity in your answer.  -3.27. In the year 2012, what is the difference between the Pupil-teacher ratio(headcount basis) of Czech Republic and Pupil-teacher ratio(headcount basis) of Peru?
Ensure brevity in your answer.  -0.21. In the year 2012, what is the difference between the Pupil-teacher ratio(headcount basis) in Czech Republic and Pupil-teacher ratio(headcount basis) in Saudi Arabia?
Your answer should be compact. 8.09. In the year 2012, what is the difference between the Pupil-teacher ratio(headcount basis) in Czech Republic and Pupil-teacher ratio(headcount basis) in United States?
Your answer should be very brief. 4.55. In the year 2012, what is the difference between the Pupil-teacher ratio(headcount basis) in Peru and Pupil-teacher ratio(headcount basis) in Saudi Arabia?
Your answer should be compact. 8.3. In the year 2012, what is the difference between the Pupil-teacher ratio(headcount basis) of Peru and Pupil-teacher ratio(headcount basis) of United States?
Give a very brief answer. 4.77. In the year 2012, what is the difference between the Pupil-teacher ratio(headcount basis) in Saudi Arabia and Pupil-teacher ratio(headcount basis) in United States?
Provide a short and direct response. -3.54. What is the ratio of the Pupil-teacher ratio(headcount basis) in Czech Republic in 2005 to that in 2007?
Provide a short and direct response. 0.87. What is the ratio of the Pupil-teacher ratio(headcount basis) of Peru in 2005 to that in 2007?
Keep it short and to the point. 1.06. What is the ratio of the Pupil-teacher ratio(headcount basis) of Saudi Arabia in 2005 to that in 2007?
Provide a succinct answer. 1.01. What is the ratio of the Pupil-teacher ratio(headcount basis) of United States in 2005 to that in 2007?
Make the answer very short. 1.02. What is the ratio of the Pupil-teacher ratio(headcount basis) in Czech Republic in 2005 to that in 2008?
Provide a succinct answer. 0.88. What is the ratio of the Pupil-teacher ratio(headcount basis) of Peru in 2005 to that in 2008?
Your answer should be very brief. 1.1. What is the ratio of the Pupil-teacher ratio(headcount basis) of Saudi Arabia in 2005 to that in 2008?
Keep it short and to the point. 1.05. What is the ratio of the Pupil-teacher ratio(headcount basis) in United States in 2005 to that in 2008?
Keep it short and to the point. 1.03. What is the ratio of the Pupil-teacher ratio(headcount basis) in Czech Republic in 2005 to that in 2009?
Offer a very short reply. 0.88. What is the ratio of the Pupil-teacher ratio(headcount basis) in Peru in 2005 to that in 2009?
Your answer should be very brief. 1.14. What is the ratio of the Pupil-teacher ratio(headcount basis) in Saudi Arabia in 2005 to that in 2009?
Ensure brevity in your answer.  0.99. What is the ratio of the Pupil-teacher ratio(headcount basis) in United States in 2005 to that in 2009?
Your answer should be very brief. 1.02. What is the ratio of the Pupil-teacher ratio(headcount basis) of Czech Republic in 2005 to that in 2010?
Ensure brevity in your answer.  0.87. What is the ratio of the Pupil-teacher ratio(headcount basis) in Peru in 2005 to that in 2010?
Ensure brevity in your answer.  1.17. What is the ratio of the Pupil-teacher ratio(headcount basis) in Saudi Arabia in 2005 to that in 2010?
Offer a very short reply. 1.02. What is the ratio of the Pupil-teacher ratio(headcount basis) in United States in 2005 to that in 2010?
Your answer should be compact. 1.04. What is the ratio of the Pupil-teacher ratio(headcount basis) in Czech Republic in 2005 to that in 2011?
Provide a short and direct response. 0.86. What is the ratio of the Pupil-teacher ratio(headcount basis) of Peru in 2005 to that in 2011?
Your answer should be compact. 1.18. What is the ratio of the Pupil-teacher ratio(headcount basis) in Saudi Arabia in 2005 to that in 2011?
Keep it short and to the point. 1.03. What is the ratio of the Pupil-teacher ratio(headcount basis) of Czech Republic in 2005 to that in 2012?
Make the answer very short. 0.86. What is the ratio of the Pupil-teacher ratio(headcount basis) in Peru in 2005 to that in 2012?
Ensure brevity in your answer.  1.2. What is the ratio of the Pupil-teacher ratio(headcount basis) in Saudi Arabia in 2005 to that in 2012?
Your answer should be compact. 1.04. What is the ratio of the Pupil-teacher ratio(headcount basis) of United States in 2005 to that in 2012?
Your response must be concise. 0.98. What is the ratio of the Pupil-teacher ratio(headcount basis) in Czech Republic in 2007 to that in 2008?
Offer a terse response. 1.01. What is the ratio of the Pupil-teacher ratio(headcount basis) of Peru in 2007 to that in 2008?
Your answer should be very brief. 1.04. What is the ratio of the Pupil-teacher ratio(headcount basis) in Saudi Arabia in 2007 to that in 2008?
Keep it short and to the point. 1.04. What is the ratio of the Pupil-teacher ratio(headcount basis) of United States in 2007 to that in 2008?
Offer a very short reply. 1.01. What is the ratio of the Pupil-teacher ratio(headcount basis) of Czech Republic in 2007 to that in 2009?
Give a very brief answer. 1.01. What is the ratio of the Pupil-teacher ratio(headcount basis) of Peru in 2007 to that in 2009?
Ensure brevity in your answer.  1.08. What is the ratio of the Pupil-teacher ratio(headcount basis) in Saudi Arabia in 2007 to that in 2009?
Make the answer very short. 0.98. What is the ratio of the Pupil-teacher ratio(headcount basis) in United States in 2007 to that in 2009?
Give a very brief answer. 0.99. What is the ratio of the Pupil-teacher ratio(headcount basis) of Czech Republic in 2007 to that in 2010?
Keep it short and to the point. 1. What is the ratio of the Pupil-teacher ratio(headcount basis) in Peru in 2007 to that in 2010?
Your answer should be compact. 1.11. What is the ratio of the Pupil-teacher ratio(headcount basis) of Saudi Arabia in 2007 to that in 2010?
Your response must be concise. 1.01. What is the ratio of the Pupil-teacher ratio(headcount basis) of United States in 2007 to that in 2010?
Offer a very short reply. 1.02. What is the ratio of the Pupil-teacher ratio(headcount basis) in Czech Republic in 2007 to that in 2011?
Offer a very short reply. 0.99. What is the ratio of the Pupil-teacher ratio(headcount basis) in Peru in 2007 to that in 2011?
Provide a short and direct response. 1.11. What is the ratio of the Pupil-teacher ratio(headcount basis) in Saudi Arabia in 2007 to that in 2011?
Provide a succinct answer. 1.02. What is the ratio of the Pupil-teacher ratio(headcount basis) in United States in 2007 to that in 2011?
Offer a very short reply. 0.97. What is the ratio of the Pupil-teacher ratio(headcount basis) in Peru in 2007 to that in 2012?
Your answer should be very brief. 1.14. What is the ratio of the Pupil-teacher ratio(headcount basis) of Saudi Arabia in 2007 to that in 2012?
Your response must be concise. 1.03. What is the ratio of the Pupil-teacher ratio(headcount basis) of United States in 2007 to that in 2012?
Provide a short and direct response. 0.96. What is the ratio of the Pupil-teacher ratio(headcount basis) of Peru in 2008 to that in 2009?
Give a very brief answer. 1.04. What is the ratio of the Pupil-teacher ratio(headcount basis) in Saudi Arabia in 2008 to that in 2009?
Offer a terse response. 0.94. What is the ratio of the Pupil-teacher ratio(headcount basis) of United States in 2008 to that in 2009?
Keep it short and to the point. 0.99. What is the ratio of the Pupil-teacher ratio(headcount basis) in Czech Republic in 2008 to that in 2010?
Your answer should be very brief. 0.99. What is the ratio of the Pupil-teacher ratio(headcount basis) in Peru in 2008 to that in 2010?
Keep it short and to the point. 1.06. What is the ratio of the Pupil-teacher ratio(headcount basis) in Czech Republic in 2008 to that in 2011?
Your answer should be compact. 0.98. What is the ratio of the Pupil-teacher ratio(headcount basis) in Peru in 2008 to that in 2011?
Provide a short and direct response. 1.07. What is the ratio of the Pupil-teacher ratio(headcount basis) in Saudi Arabia in 2008 to that in 2011?
Give a very brief answer. 0.98. What is the ratio of the Pupil-teacher ratio(headcount basis) of Czech Republic in 2008 to that in 2012?
Ensure brevity in your answer.  0.97. What is the ratio of the Pupil-teacher ratio(headcount basis) of Peru in 2008 to that in 2012?
Keep it short and to the point. 1.09. What is the ratio of the Pupil-teacher ratio(headcount basis) in United States in 2008 to that in 2012?
Your answer should be very brief. 0.95. What is the ratio of the Pupil-teacher ratio(headcount basis) in Czech Republic in 2009 to that in 2010?
Offer a terse response. 0.99. What is the ratio of the Pupil-teacher ratio(headcount basis) in Peru in 2009 to that in 2010?
Give a very brief answer. 1.02. What is the ratio of the Pupil-teacher ratio(headcount basis) of Saudi Arabia in 2009 to that in 2010?
Make the answer very short. 1.02. What is the ratio of the Pupil-teacher ratio(headcount basis) of United States in 2009 to that in 2010?
Your answer should be compact. 1.02. What is the ratio of the Pupil-teacher ratio(headcount basis) of Czech Republic in 2009 to that in 2011?
Your answer should be compact. 0.98. What is the ratio of the Pupil-teacher ratio(headcount basis) of Peru in 2009 to that in 2011?
Offer a terse response. 1.03. What is the ratio of the Pupil-teacher ratio(headcount basis) in Saudi Arabia in 2009 to that in 2011?
Make the answer very short. 1.04. What is the ratio of the Pupil-teacher ratio(headcount basis) in United States in 2009 to that in 2011?
Provide a short and direct response. 0.97. What is the ratio of the Pupil-teacher ratio(headcount basis) in Czech Republic in 2009 to that in 2012?
Provide a succinct answer. 0.97. What is the ratio of the Pupil-teacher ratio(headcount basis) of Peru in 2009 to that in 2012?
Your answer should be very brief. 1.05. What is the ratio of the Pupil-teacher ratio(headcount basis) in United States in 2009 to that in 2012?
Your answer should be very brief. 0.96. What is the ratio of the Pupil-teacher ratio(headcount basis) of Saudi Arabia in 2010 to that in 2011?
Your answer should be compact. 1.01. What is the ratio of the Pupil-teacher ratio(headcount basis) of United States in 2010 to that in 2011?
Give a very brief answer. 0.95. What is the ratio of the Pupil-teacher ratio(headcount basis) in Czech Republic in 2010 to that in 2012?
Ensure brevity in your answer.  0.99. What is the ratio of the Pupil-teacher ratio(headcount basis) in Peru in 2010 to that in 2012?
Your answer should be compact. 1.03. What is the ratio of the Pupil-teacher ratio(headcount basis) of Saudi Arabia in 2010 to that in 2012?
Your response must be concise. 1.02. What is the ratio of the Pupil-teacher ratio(headcount basis) of United States in 2010 to that in 2012?
Give a very brief answer. 0.94. What is the ratio of the Pupil-teacher ratio(headcount basis) of Czech Republic in 2011 to that in 2012?
Give a very brief answer. 0.99. What is the ratio of the Pupil-teacher ratio(headcount basis) of Peru in 2011 to that in 2012?
Make the answer very short. 1.02. What is the ratio of the Pupil-teacher ratio(headcount basis) of Saudi Arabia in 2011 to that in 2012?
Provide a short and direct response. 1.01. What is the difference between the highest and the second highest Pupil-teacher ratio(headcount basis) of Czech Republic?
Keep it short and to the point. 0.15. What is the difference between the highest and the second highest Pupil-teacher ratio(headcount basis) of Peru?
Offer a very short reply. 1.23. What is the difference between the highest and the second highest Pupil-teacher ratio(headcount basis) in Saudi Arabia?
Offer a very short reply. 0.1. What is the difference between the highest and the second highest Pupil-teacher ratio(headcount basis) in United States?
Ensure brevity in your answer.  0.14. What is the difference between the highest and the lowest Pupil-teacher ratio(headcount basis) of Czech Republic?
Keep it short and to the point. 2.73. What is the difference between the highest and the lowest Pupil-teacher ratio(headcount basis) of Peru?
Ensure brevity in your answer.  3.84. What is the difference between the highest and the lowest Pupil-teacher ratio(headcount basis) in Saudi Arabia?
Keep it short and to the point. 0.68. What is the difference between the highest and the lowest Pupil-teacher ratio(headcount basis) in United States?
Your answer should be compact. 0.83. 